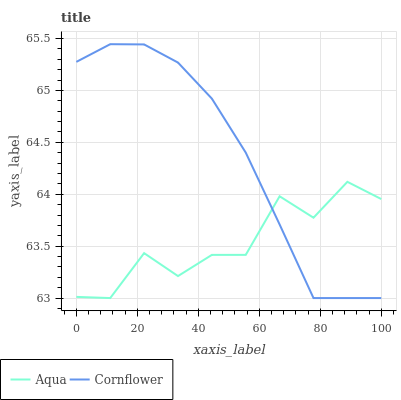Does Aqua have the maximum area under the curve?
Answer yes or no. No. Is Aqua the smoothest?
Answer yes or no. No. Does Aqua have the highest value?
Answer yes or no. No. 